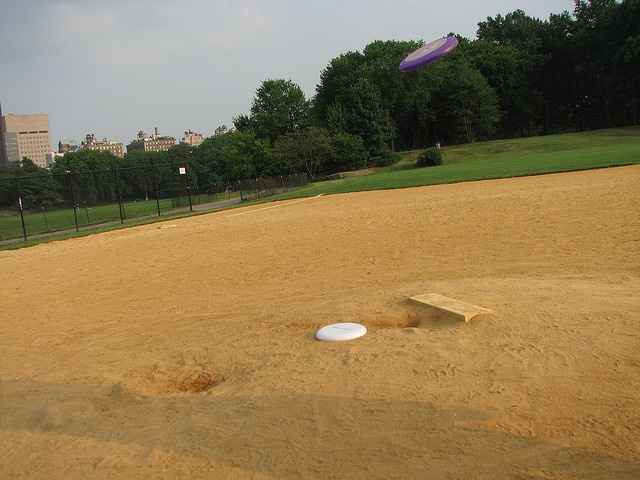Describe the objects in this image and their specific colors. I can see frisbee in darkgray and purple tones and frisbee in darkgray, lightgray, and tan tones in this image. 